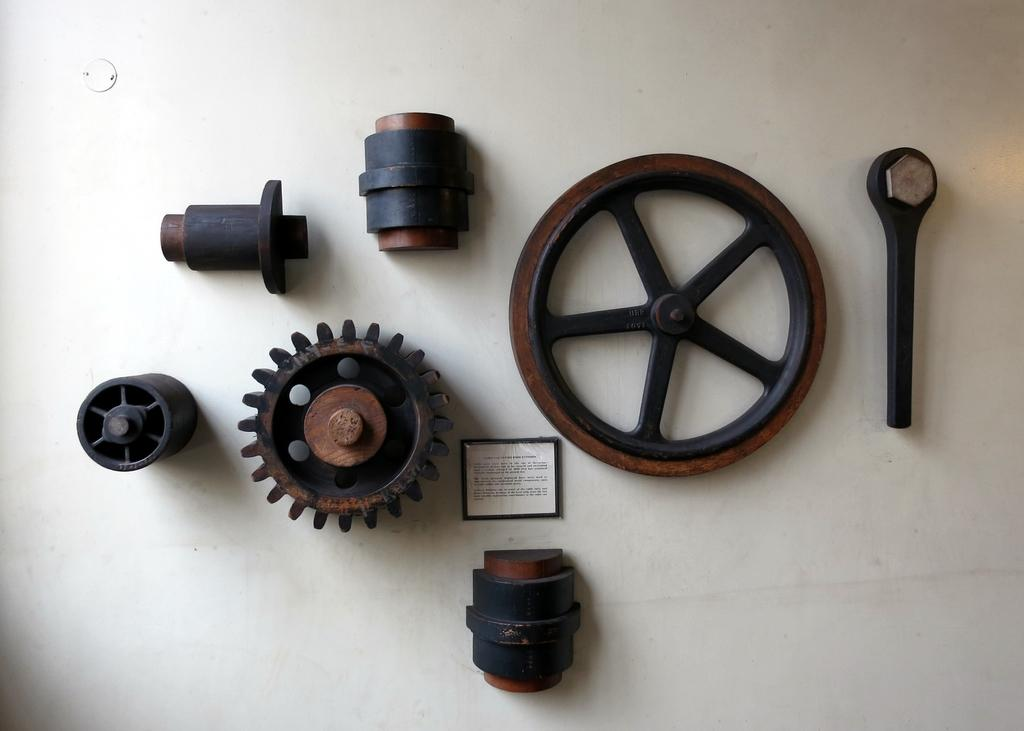What is present on the wall in the image? There are objects on the wall, including a frame. Can you describe the frame on the wall? The frame on the wall has text on it. What type of chair is depicted in the text on the frame? There is no chair depicted in the text on the frame, as the image only shows objects on the wall and a frame with text. 